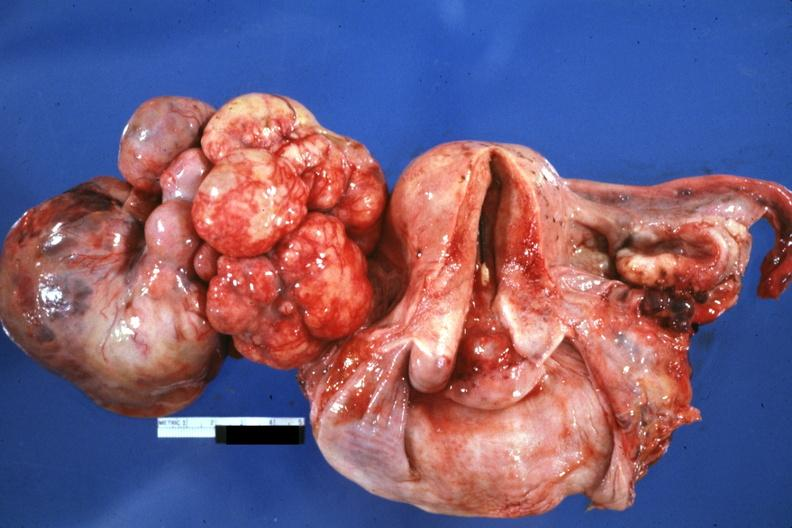what is present?
Answer the question using a single word or phrase. Female reproductive 